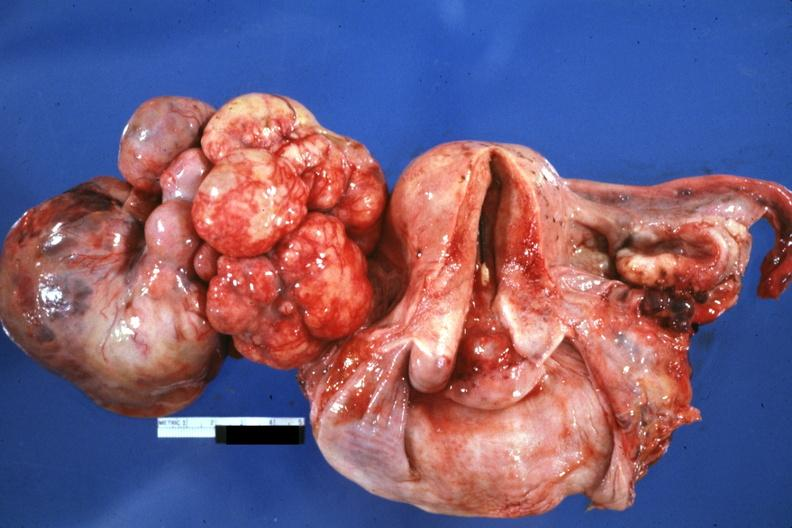what is present?
Answer the question using a single word or phrase. Female reproductive 